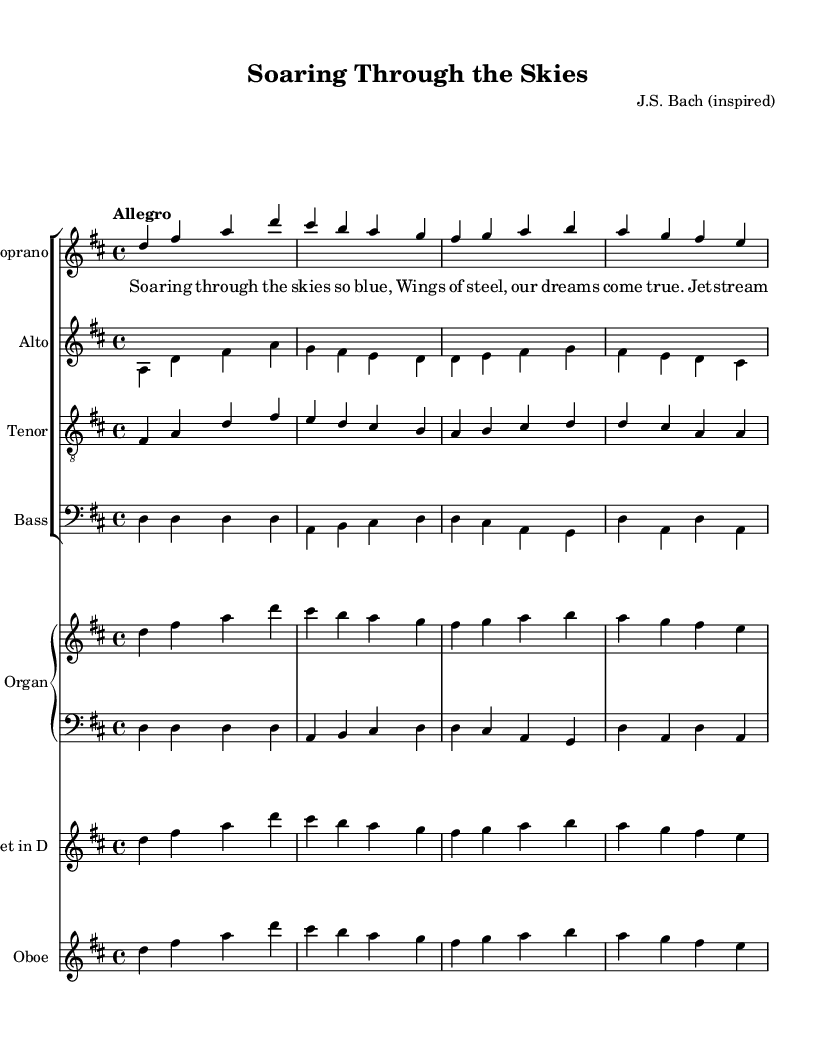What is the key signature of this music? The key signature indicated in the music is D major, which has two sharps (F# and C#). This can be determined by looking at the key signature symbol at the beginning of the music score.
Answer: D major What is the time signature of this piece? The time signature is 4/4, which indicates that there are four beats per measure and a quarter note receives one beat. This information is found at the start of the score, where the time signature notation is placed.
Answer: 4/4 What is the tempo marking for this music? The tempo marking is "Allegro," which suggests a fast, lively pace. This can be identified by looking at the tempo indication specified in the header section of the music.
Answer: Allegro How many voices are there in the choral arrangement? The choral arrangement consists of four voices: soprano, alto, tenor, and bass. This can be seen by examining the layout of the score, which clearly delineates each vocal part within the choir staff.
Answer: Four Which instrument plays the soprano line? The soprano line is played by the choir voices as indicated by the staff labeled "Soprano." Additionally, it is also notated for organ and trumpet, which means that both the choir and those instruments can perform the soprano part.
Answer: Soprano What is the primary theme expressed in the lyrics? The primary theme expressed in the lyrics revolves around the concept of soaring and adventure, particularly in the context of air travel and dreams coming true. Analyzing the lyrics provides insight into the adventurous feeling conveyed throughout the piece.
Answer: Adventure Which instrument is associated with the transposition for the trumpet? The trumpet is associated with the transposition to D, which requires reading music in a different pitch. This is indicated in the score where the trumpet staff shows a transposition mark at the beginning.
Answer: Trumpet in D 